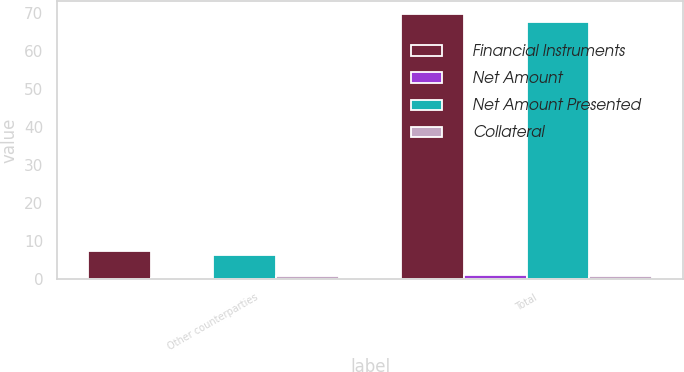Convert chart to OTSL. <chart><loc_0><loc_0><loc_500><loc_500><stacked_bar_chart><ecel><fcel>Other counterparties<fcel>Total<nl><fcel>Financial Instruments<fcel>7.4<fcel>69.7<nl><fcel>Net Amount<fcel>0.2<fcel>1.2<nl><fcel>Net Amount Presented<fcel>6.4<fcel>67.6<nl><fcel>Collateral<fcel>0.8<fcel>0.9<nl></chart> 